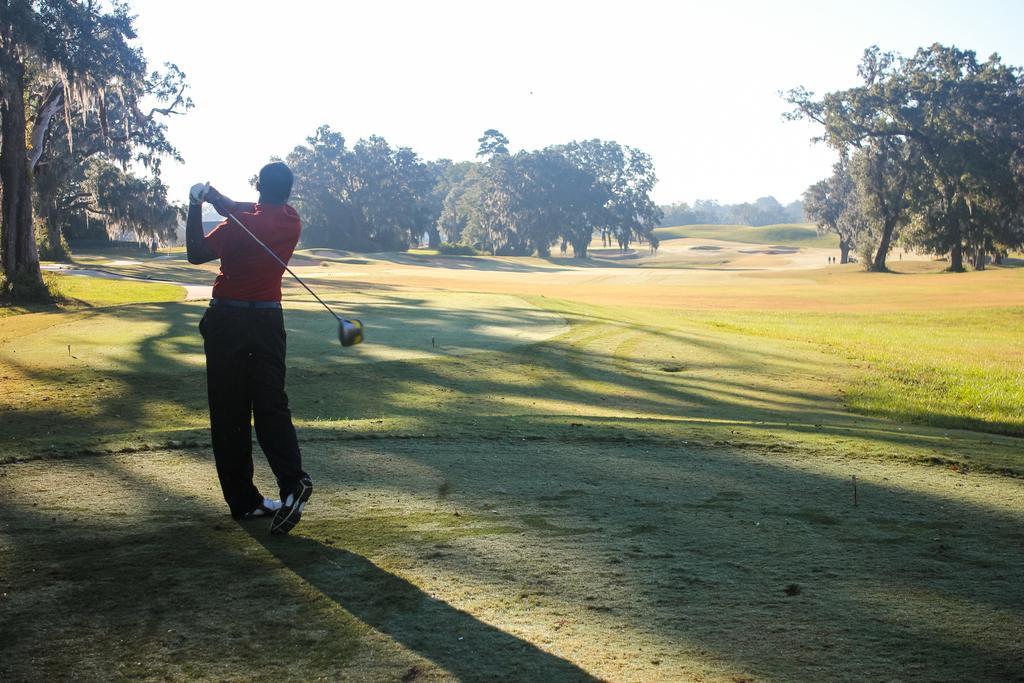How would you summarize this image in a sentence or two? In this image there is one person standing and holding a Golf bat at left side of this image and there are some trees in the background. There is a sky at top of this image and there is a ground at bottom of this image. 